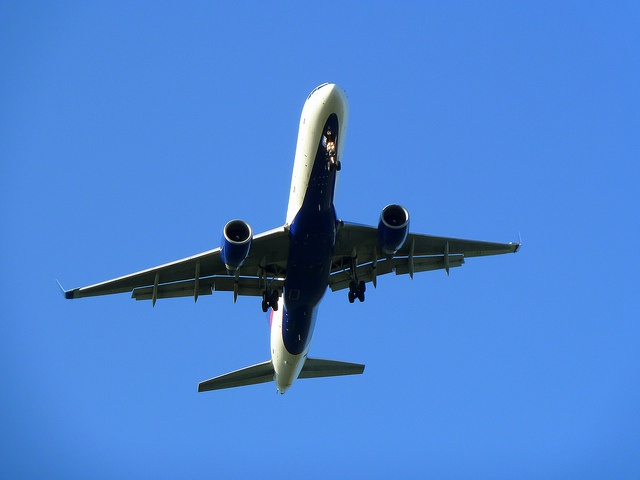Describe the objects in this image and their specific colors. I can see a airplane in gray, black, and ivory tones in this image. 